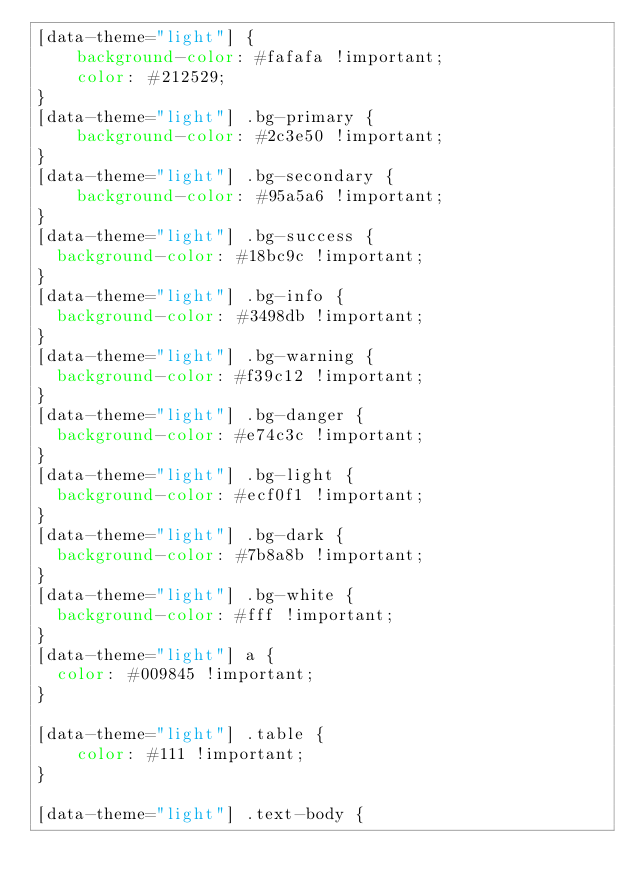Convert code to text. <code><loc_0><loc_0><loc_500><loc_500><_CSS_>[data-theme="light"] {
    background-color: #fafafa !important;
    color: #212529;
}
[data-theme="light"] .bg-primary {
    background-color: #2c3e50 !important;
}
[data-theme="light"] .bg-secondary {
    background-color: #95a5a6 !important;
}
[data-theme="light"] .bg-success {
  background-color: #18bc9c !important;
}
[data-theme="light"] .bg-info {
  background-color: #3498db !important;
}
[data-theme="light"] .bg-warning {
  background-color: #f39c12 !important;
}
[data-theme="light"] .bg-danger {
  background-color: #e74c3c !important;
}
[data-theme="light"] .bg-light {
  background-color: #ecf0f1 !important;
}
[data-theme="light"] .bg-dark {
  background-color: #7b8a8b !important;
}
[data-theme="light"] .bg-white {
  background-color: #fff !important;
}
[data-theme="light"] a {
  color: #009845 !important;
}

[data-theme="light"] .table {
    color: #111 !important;
}

[data-theme="light"] .text-body {</code> 